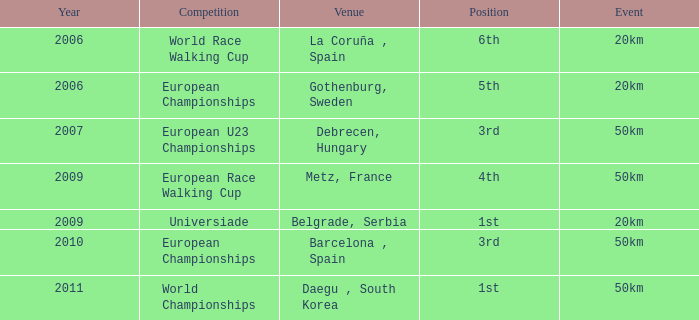Which Competition has an Event of 50km, a Year earlier than 2010 and a Position of 3rd? European U23 Championships. Give me the full table as a dictionary. {'header': ['Year', 'Competition', 'Venue', 'Position', 'Event'], 'rows': [['2006', 'World Race Walking Cup', 'La Coruña , Spain', '6th', '20km'], ['2006', 'European Championships', 'Gothenburg, Sweden', '5th', '20km'], ['2007', 'European U23 Championships', 'Debrecen, Hungary', '3rd', '50km'], ['2009', 'European Race Walking Cup', 'Metz, France', '4th', '50km'], ['2009', 'Universiade', 'Belgrade, Serbia', '1st', '20km'], ['2010', 'European Championships', 'Barcelona , Spain', '3rd', '50km'], ['2011', 'World Championships', 'Daegu , South Korea', '1st', '50km']]} 